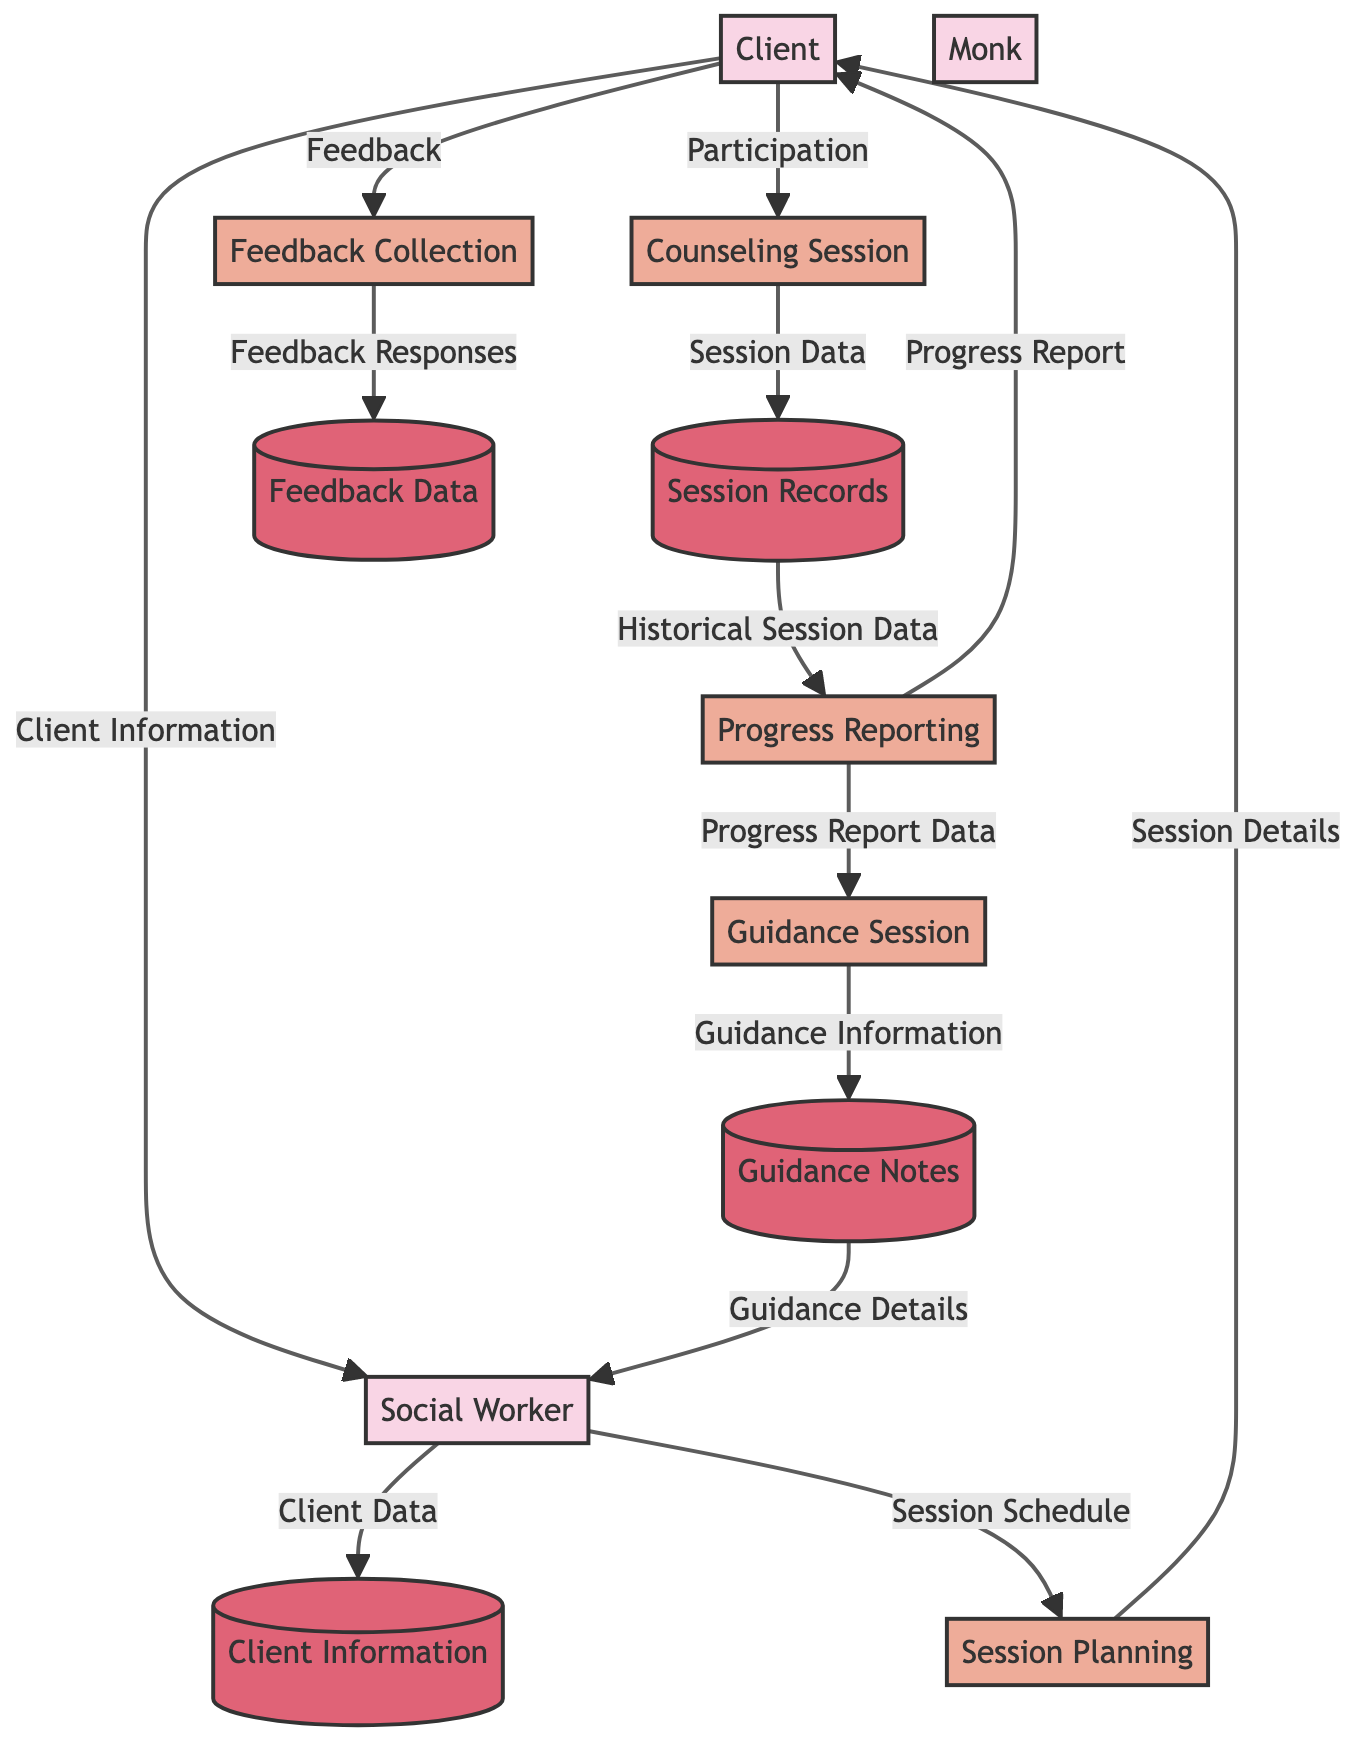What is the main entity that facilitates relationship counseling sessions? The main entity that facilitates relationship counseling sessions is the Social Worker, identified in the diagram as "SW." This entity initiates and manages the counseling process.
Answer: Social Worker How many main processes are involved in the counseling flow? The diagram lists five main processes: Session Planning, Counseling Session, Progress Reporting, Feedback Collection, and Guidance Session. Counting these processes gives a total of five.
Answer: 5 Which entity provides feedback about the counseling session? The feedback about the counseling session is provided by the Client, who is depicted as "C" in the diagram and directly links to the Feedback Collection process.
Answer: Client What type of information does the Social Worker send to the Monk? The Social Worker sends Progress Report Data to the Monk during the Guidance Session. This information is critical for receiving tailored spiritual insights and advice.
Answer: Progress Report Data How many data stores are present in the diagram? The diagram includes four data stores, specifically: Client Information, Session Records, Feedback Data, and Guidance Notes. Counting these stores shows that there are four in total.
Answer: 4 What is the flow of data from the Counseling Session to Progress Reporting? The flow of data moves from the Counseling Session, represented by "CS," to the Session Records, which stores the session details. This data is then sent to Progress Reporting as Historical Session Data. Thus, the steps are Counseling Session to Session Records to Progress Reporting.
Answer: Historical Session Data From which entity does the Social Worker receive guidance notes? The Social Worker receives guidance notes from the Monk after a Guidance Session, where the Monk provides Guidance Information based on previous reports.
Answer: Monk In which process does the Client provide their feedback? The Client provides feedback during the Feedback Collection process, which allows the social worker to gather insights on the client's experiences in the counseling session.
Answer: Feedback Collection How does the Client receive details of their scheduled counseling session? The Client receives the session details through a flow from the Session Planning process, where the social worker schedules the sessions and informs the client accordingly.
Answer: Session Details 